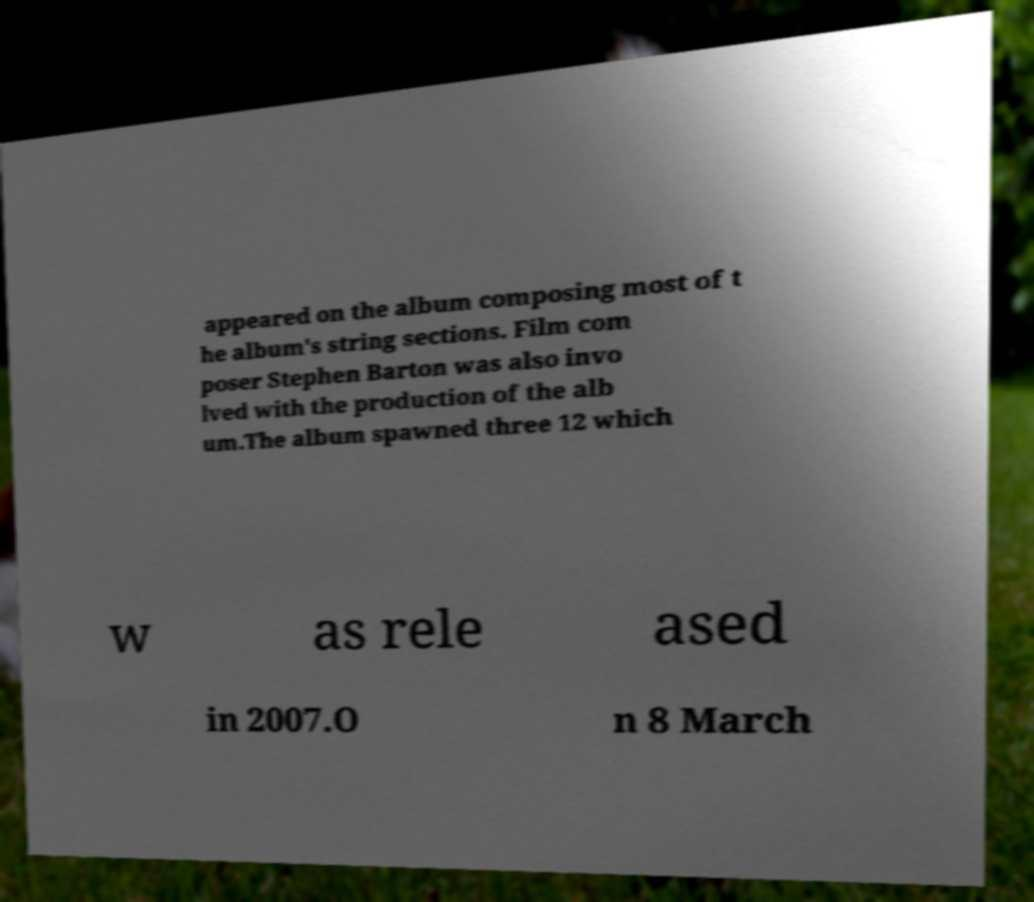Can you accurately transcribe the text from the provided image for me? appeared on the album composing most of t he album's string sections. Film com poser Stephen Barton was also invo lved with the production of the alb um.The album spawned three 12 which w as rele ased in 2007.O n 8 March 